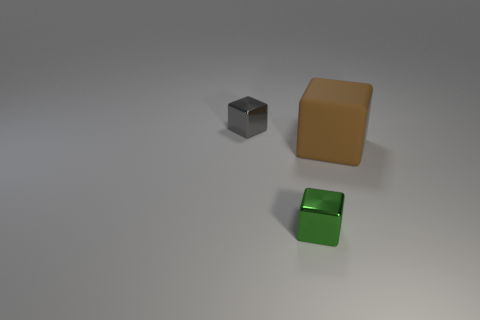Add 1 small gray cubes. How many objects exist? 4 Subtract 0 red cylinders. How many objects are left? 3 Subtract all purple rubber cylinders. Subtract all gray metallic cubes. How many objects are left? 2 Add 2 big objects. How many big objects are left? 3 Add 2 large cubes. How many large cubes exist? 3 